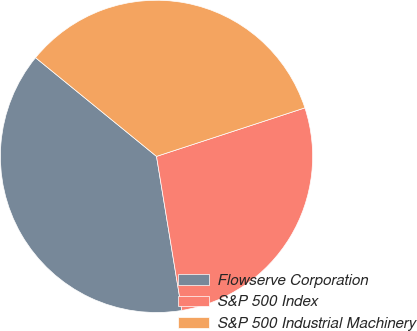Convert chart to OTSL. <chart><loc_0><loc_0><loc_500><loc_500><pie_chart><fcel>Flowserve Corporation<fcel>S&P 500 Index<fcel>S&P 500 Industrial Machinery<nl><fcel>38.48%<fcel>27.44%<fcel>34.08%<nl></chart> 